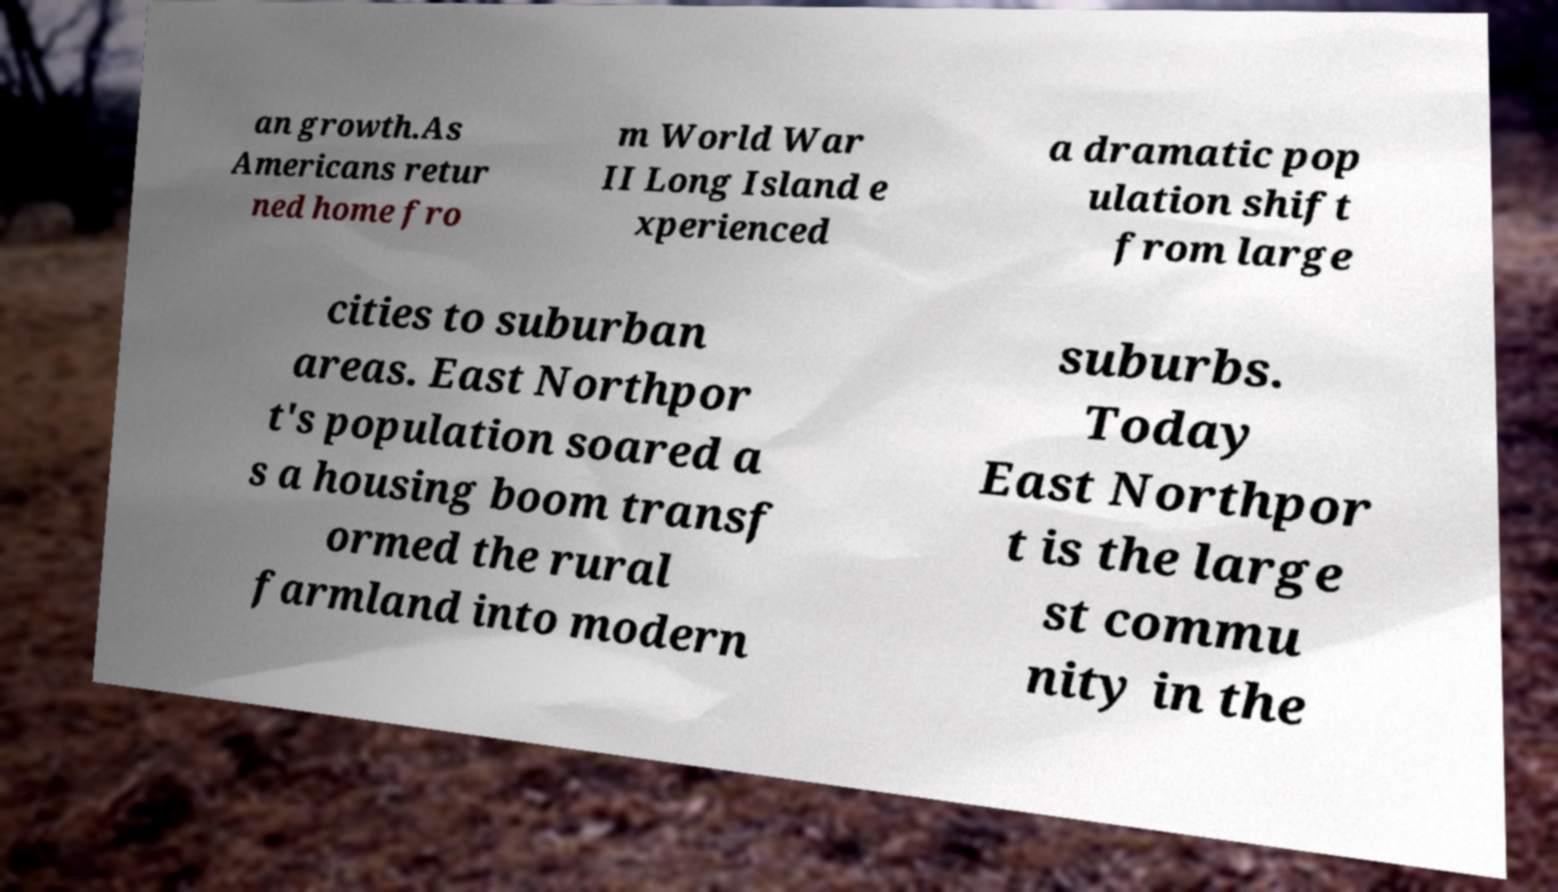For documentation purposes, I need the text within this image transcribed. Could you provide that? an growth.As Americans retur ned home fro m World War II Long Island e xperienced a dramatic pop ulation shift from large cities to suburban areas. East Northpor t's population soared a s a housing boom transf ormed the rural farmland into modern suburbs. Today East Northpor t is the large st commu nity in the 